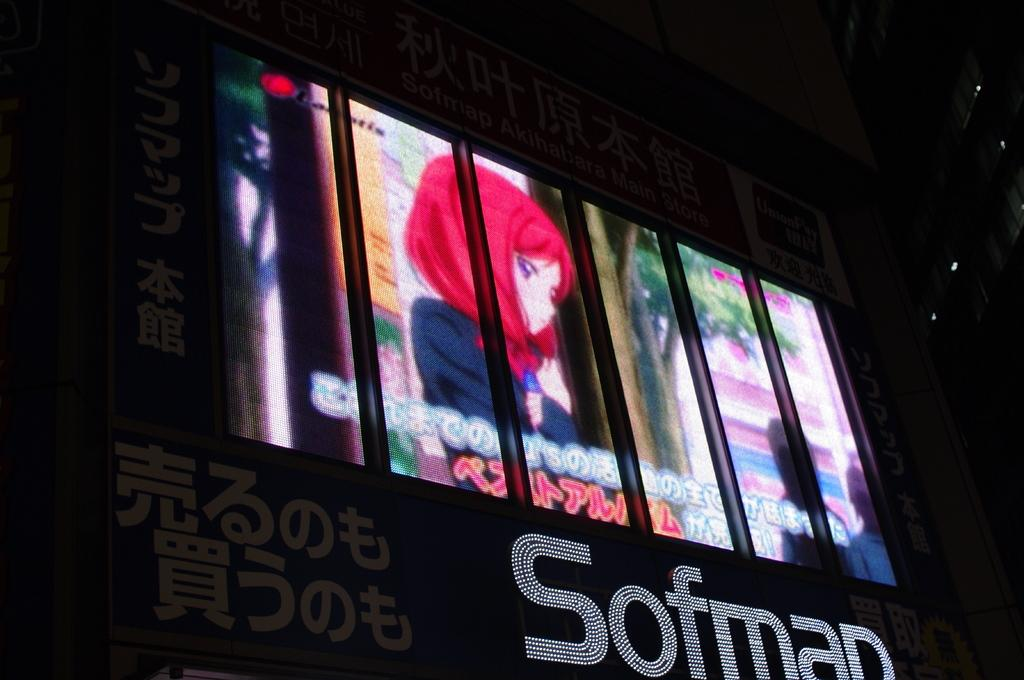What is the main object in the image? There is a banner board in the image. What is depicted on the banner board? A cartoon is present on the banner board. How many islands can be seen in the image? There are no islands present in the image; it features a banner board with a cartoon. What type of design is used for the cartoon on the banner board? The provided facts do not mention the design of the cartoon on the banner board, so it cannot be determined from the image. 